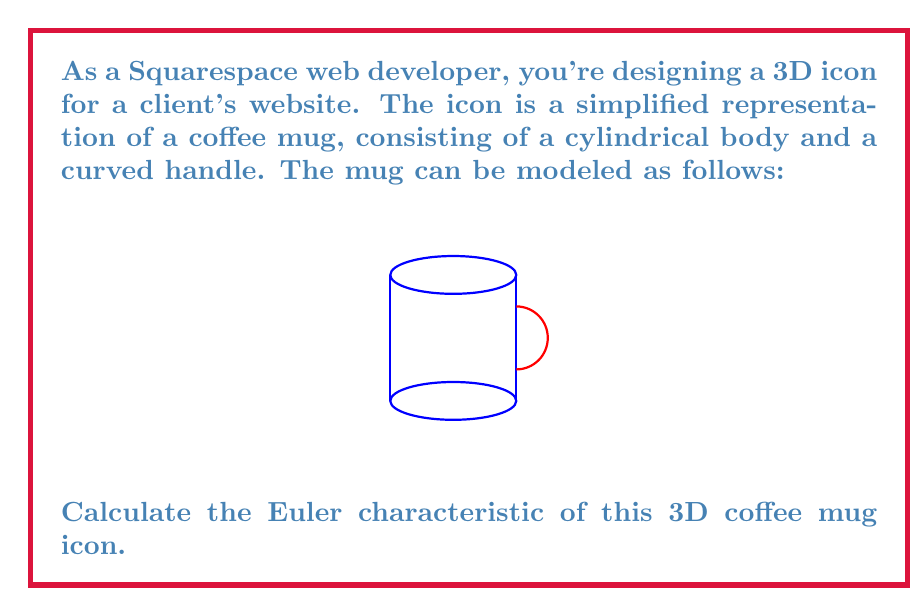Solve this math problem. To calculate the Euler characteristic of the coffee mug icon, we need to follow these steps:

1) Recall the formula for the Euler characteristic:
   $$\chi = V - E + F$$
   where $V$ is the number of vertices, $E$ is the number of edges, and $F$ is the number of faces.

2) Analyze the components of the mug:
   - The cylindrical body can be represented as two circular faces (top and bottom) connected by a rectangular face (the side).
   - The handle can be represented as a curved rectangular strip.

3) Count the elements:
   - Vertices (V): The cylinder has no vertices in its smooth form. The handle, when connected to the body, adds no new vertices. So, $V = 0$.
   
   - Edges (E): In a smooth representation, there are no distinct edges. $E = 0$.
   
   - Faces (F): 
     * Cylinder body: 3 faces (top, bottom, side)
     * Handle: 1 face
     Total faces: $F = 3 + 1 = 4$

4) Apply the formula:
   $$\chi = V - E + F = 0 - 0 + 4 = 4$$

5) Topological consideration:
   The coffee mug is topologically equivalent to a torus (donut shape). A torus has an Euler characteristic of 0.

6) The discrepancy between our calculation (4) and the expected value (0) is due to our simplified representation. In a true topological sense, the mug should be considered as a single continuous surface without distinct faces.
Answer: $\chi = 0$ 